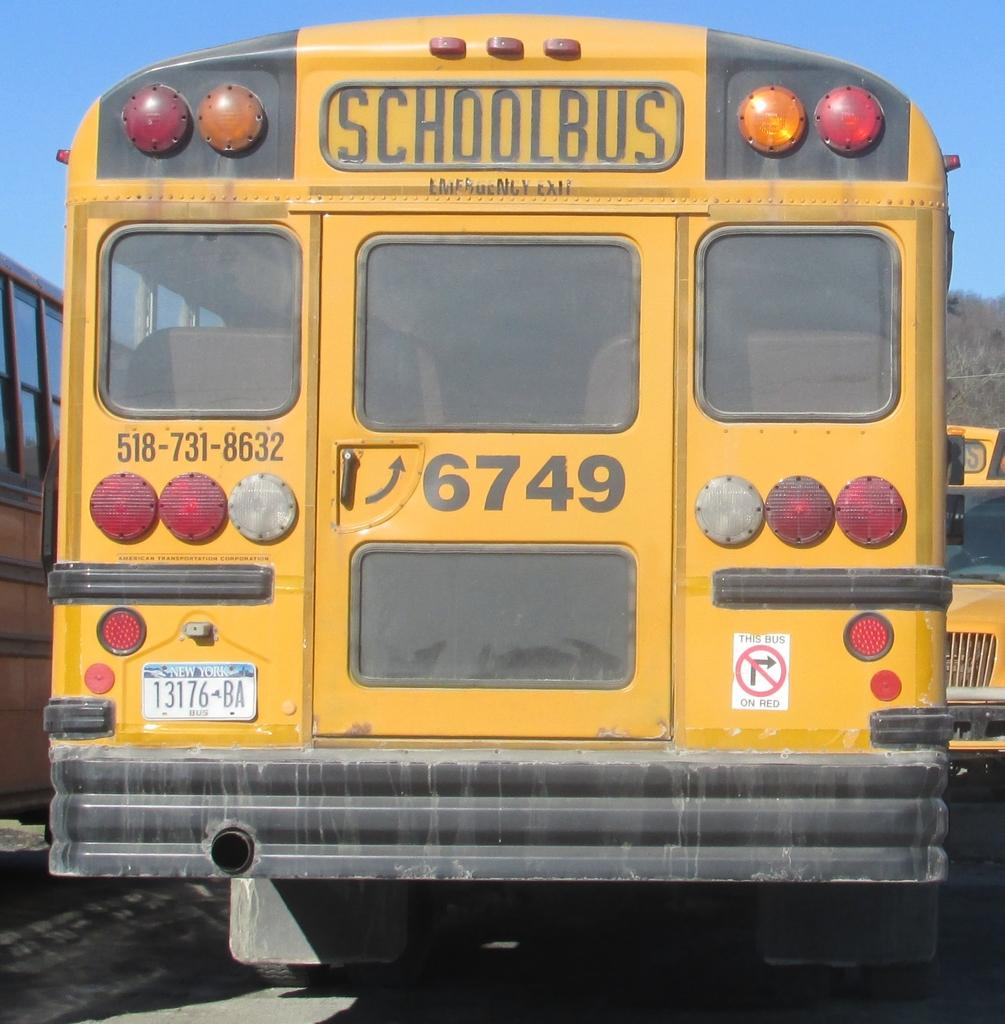<image>
Offer a succinct explanation of the picture presented. parked yellow school bus number 6749 has new york plates on it 